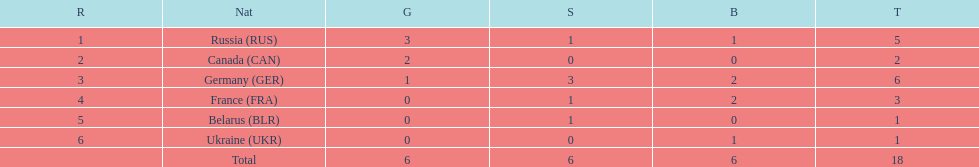What country had the most medals total at the the 1994 winter olympics biathlon? Germany (GER). 